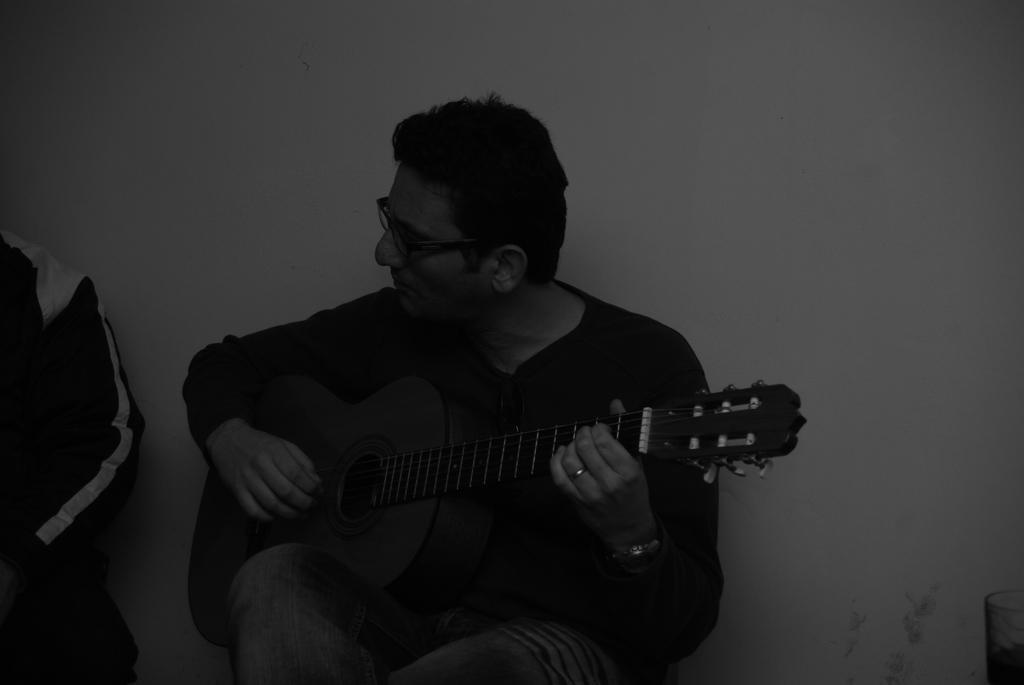Describe this image in one or two sentences. If the image a man is sitting to the wall,he is playing the guitar,he is wearing spectacles he is looking to his left side, there is another person sitting beside him to his left, in the background there is a wall. 